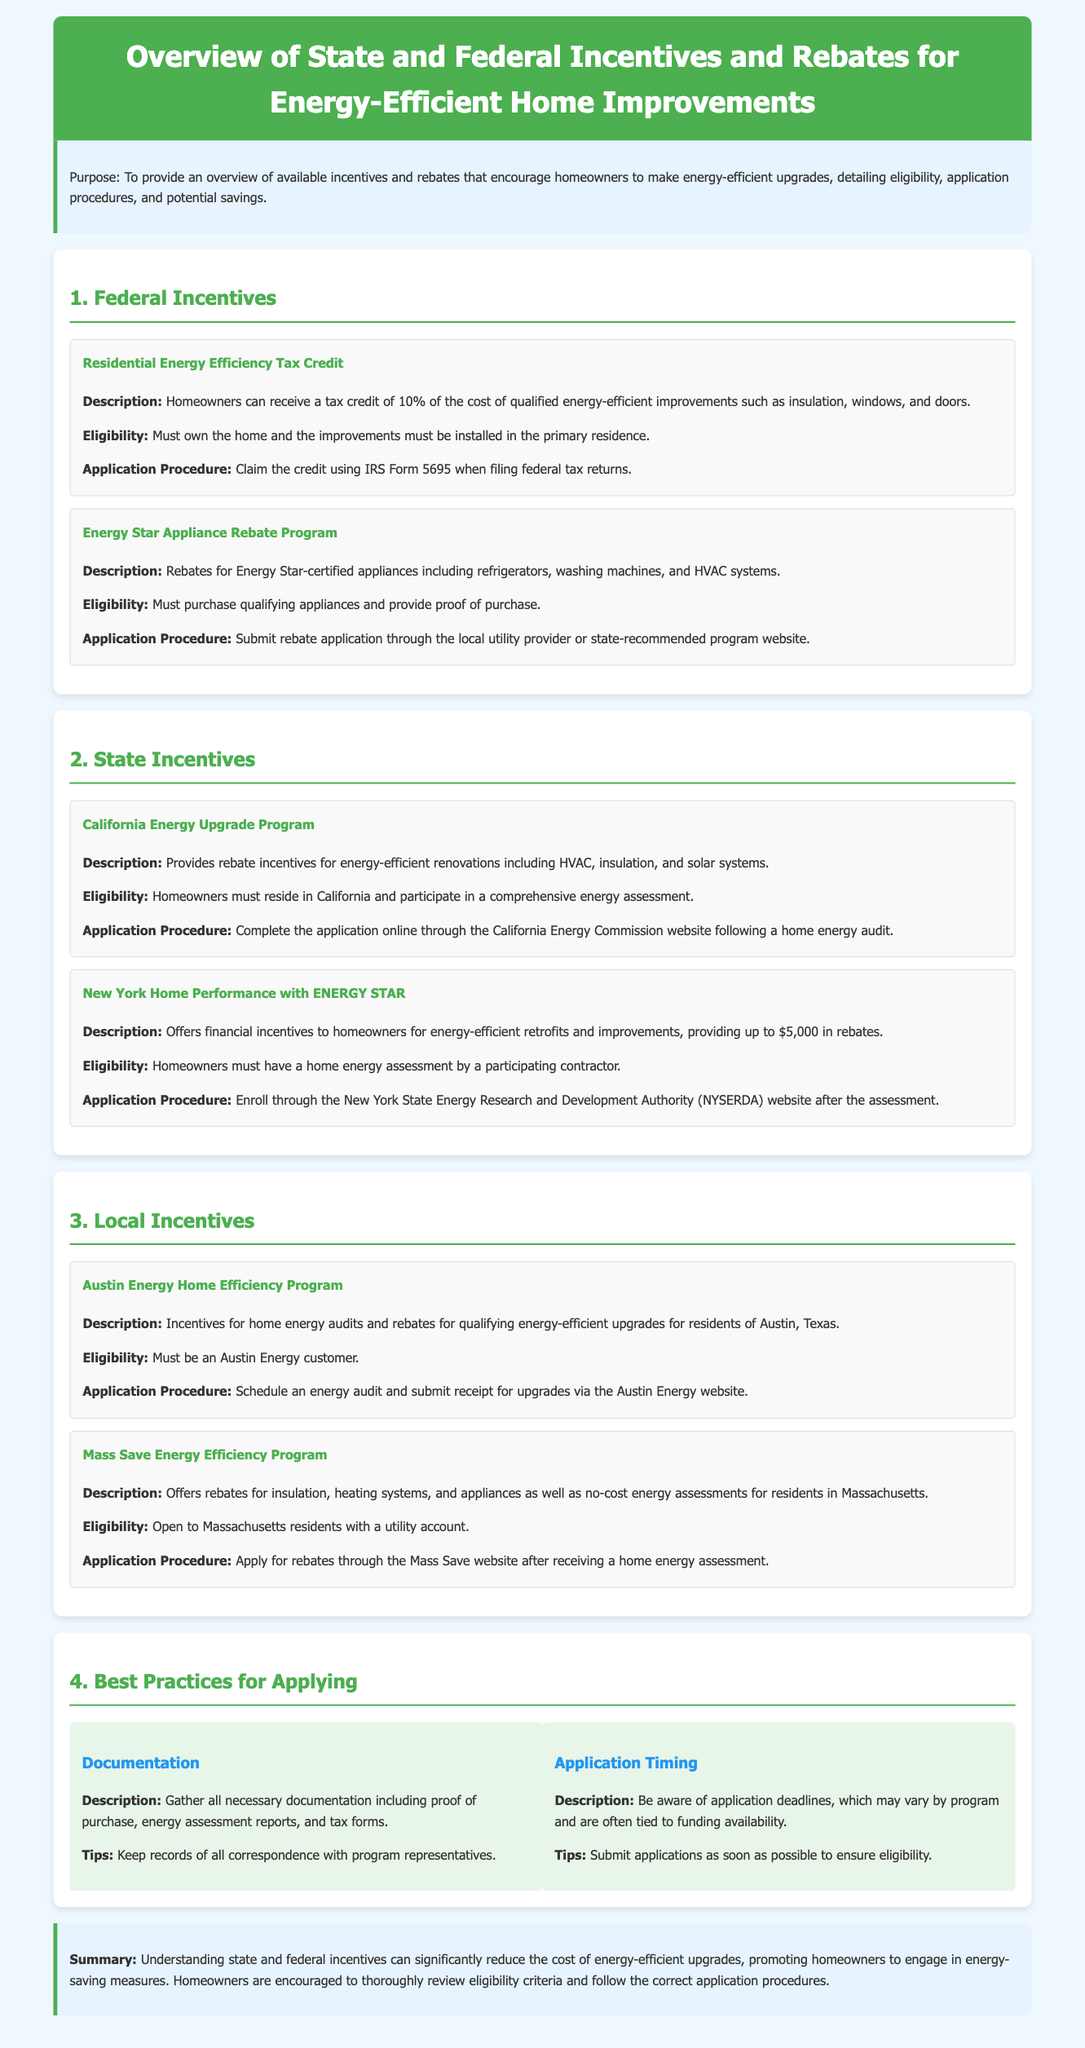What is the federal tax credit percentage for energy-efficient improvements? The federal tax credit for qualified energy-efficient improvements is 10%.
Answer: 10% Who administers the New York Home Performance with ENERGY STAR program? The New York State Energy Research and Development Authority (NYSERDA) administers this program.
Answer: NYSERDA How much can homeowners receive in rebates from the New York Home Performance program? Homeowners can receive up to $5,000 in rebates for energy-efficient retrofits and improvements.
Answer: $5,000 What must homeowners do to qualify for the California Energy Upgrade Program? Homeowners must participate in a comprehensive energy assessment to qualify.
Answer: Participate in a comprehensive energy assessment What is the eligibility requirement for the Austin Energy Home Efficiency Program? The eligibility requirement is that one must be an Austin Energy customer.
Answer: Austin Energy customer What type of documentation is essential for applying for incentives? Essential documentation includes proof of purchase, energy assessment reports, and tax forms.
Answer: Proof of purchase, energy assessment reports, and tax forms When should applications be submitted to ensure eligibility? Applications should be submitted as soon as possible to ensure eligibility.
Answer: As soon as possible What is one of the main purposes of the document? The main purpose of the document is to provide an overview of available incentives and rebates for homeowners.
Answer: Overview of available incentives and rebates 